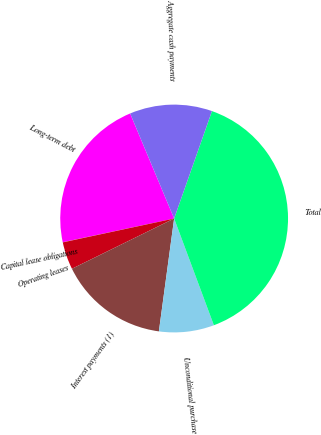Convert chart. <chart><loc_0><loc_0><loc_500><loc_500><pie_chart><fcel>Long-term debt<fcel>Capital lease obligations<fcel>Operating leases<fcel>Interest payments (1)<fcel>Unconditional purchase<fcel>Total<fcel>Aggregate cash payments<nl><fcel>22.03%<fcel>0.02%<fcel>3.91%<fcel>15.59%<fcel>7.81%<fcel>38.94%<fcel>11.7%<nl></chart> 